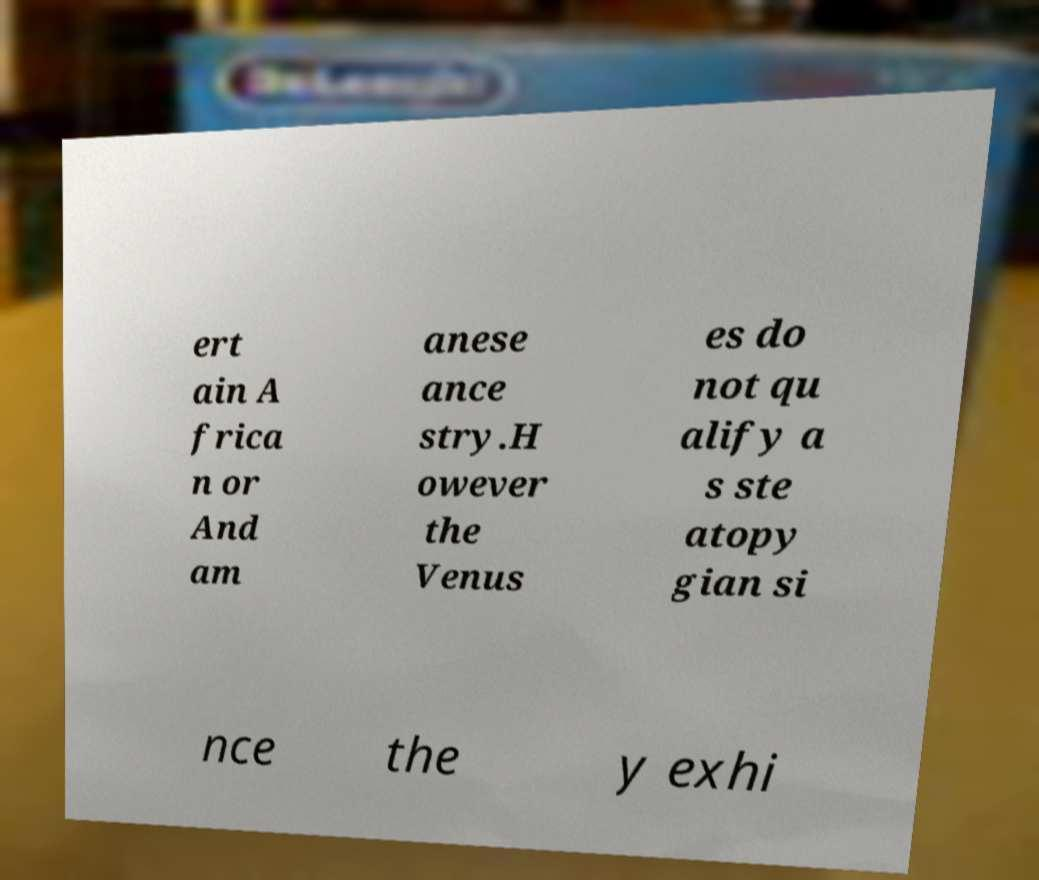Could you assist in decoding the text presented in this image and type it out clearly? ert ain A frica n or And am anese ance stry.H owever the Venus es do not qu alify a s ste atopy gian si nce the y exhi 